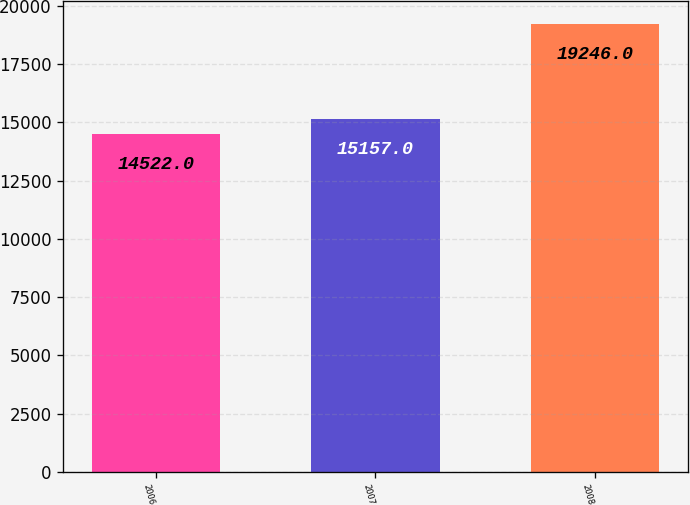Convert chart to OTSL. <chart><loc_0><loc_0><loc_500><loc_500><bar_chart><fcel>2006<fcel>2007<fcel>2008<nl><fcel>14522<fcel>15157<fcel>19246<nl></chart> 